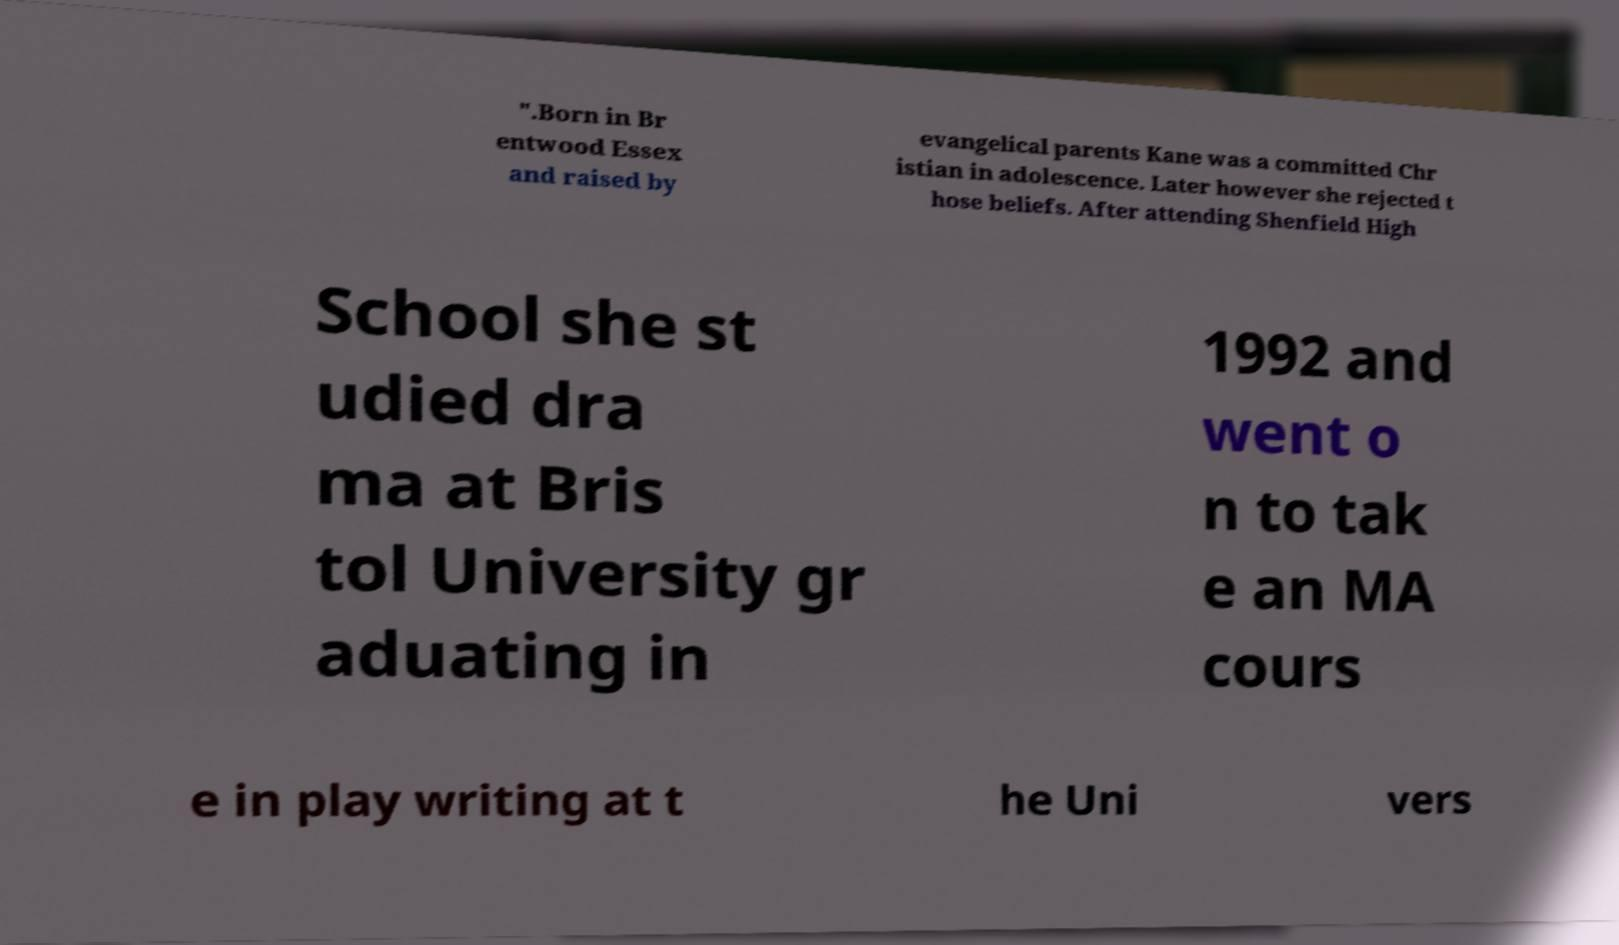Please identify and transcribe the text found in this image. ".Born in Br entwood Essex and raised by evangelical parents Kane was a committed Chr istian in adolescence. Later however she rejected t hose beliefs. After attending Shenfield High School she st udied dra ma at Bris tol University gr aduating in 1992 and went o n to tak e an MA cours e in play writing at t he Uni vers 